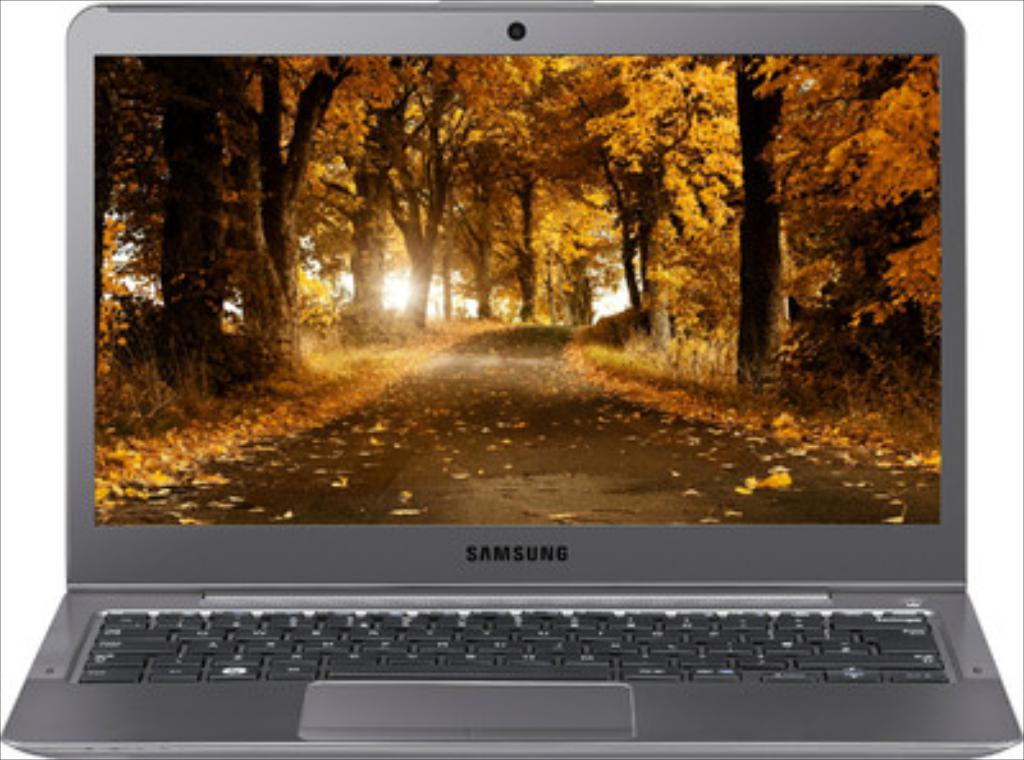<image>
Write a terse but informative summary of the picture. A samsung computer sits open with the background being a fall scene. 